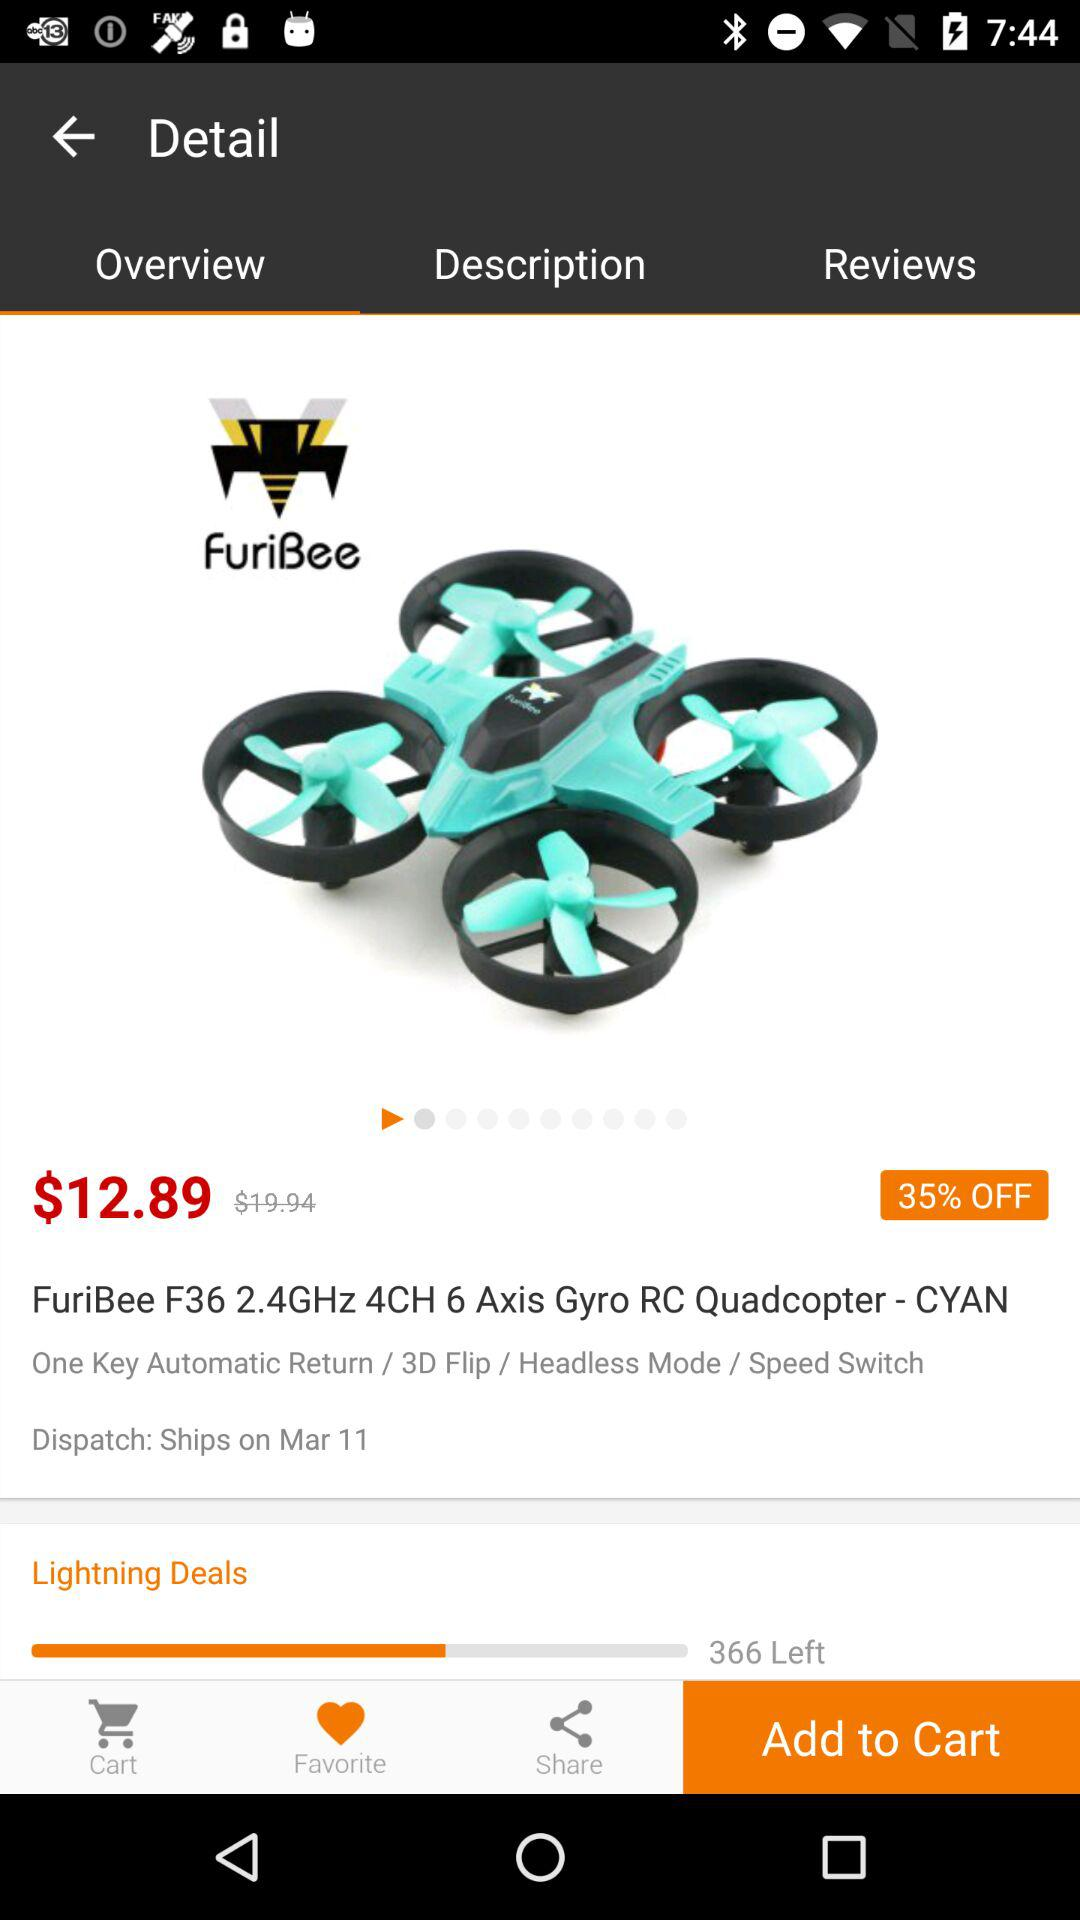How much less is the original price than the discounted price?
Answer the question using a single word or phrase. $7.05 